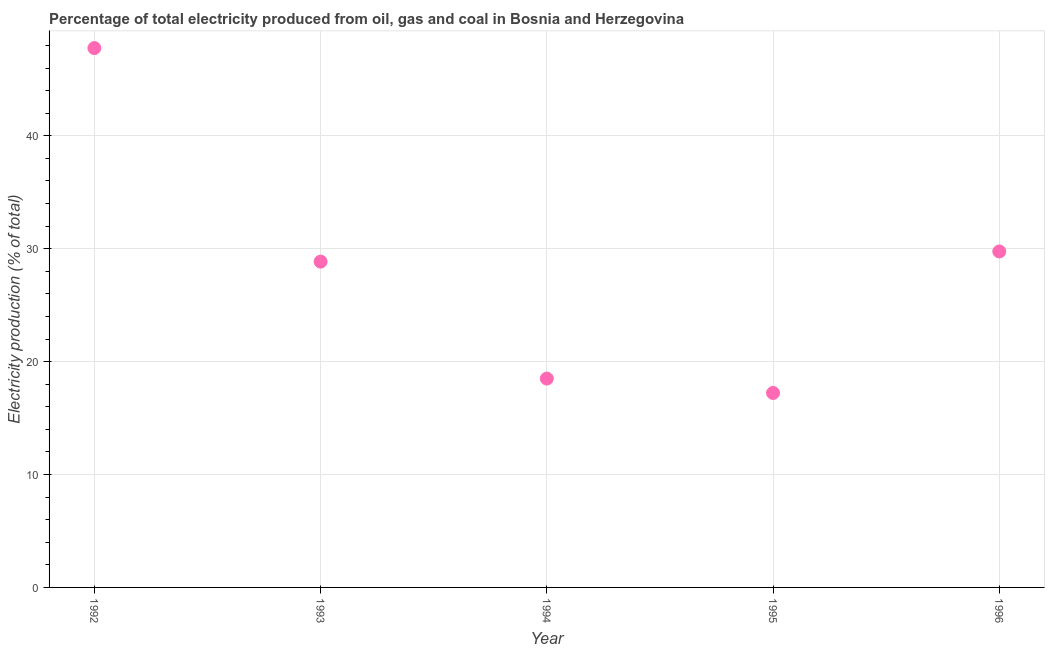What is the electricity production in 1992?
Keep it short and to the point. 47.77. Across all years, what is the maximum electricity production?
Ensure brevity in your answer.  47.77. Across all years, what is the minimum electricity production?
Offer a very short reply. 17.22. In which year was the electricity production minimum?
Offer a terse response. 1995. What is the sum of the electricity production?
Keep it short and to the point. 142.1. What is the difference between the electricity production in 1993 and 1995?
Your answer should be compact. 11.63. What is the average electricity production per year?
Make the answer very short. 28.42. What is the median electricity production?
Keep it short and to the point. 28.85. In how many years, is the electricity production greater than 34 %?
Offer a terse response. 1. What is the ratio of the electricity production in 1992 to that in 1996?
Give a very brief answer. 1.61. Is the difference between the electricity production in 1993 and 1996 greater than the difference between any two years?
Give a very brief answer. No. What is the difference between the highest and the second highest electricity production?
Provide a short and direct response. 18.02. What is the difference between the highest and the lowest electricity production?
Offer a very short reply. 30.55. In how many years, is the electricity production greater than the average electricity production taken over all years?
Offer a very short reply. 3. How many dotlines are there?
Offer a terse response. 1. Are the values on the major ticks of Y-axis written in scientific E-notation?
Give a very brief answer. No. Does the graph contain grids?
Provide a short and direct response. Yes. What is the title of the graph?
Your answer should be very brief. Percentage of total electricity produced from oil, gas and coal in Bosnia and Herzegovina. What is the label or title of the X-axis?
Provide a succinct answer. Year. What is the label or title of the Y-axis?
Give a very brief answer. Electricity production (% of total). What is the Electricity production (% of total) in 1992?
Your answer should be compact. 47.77. What is the Electricity production (% of total) in 1993?
Keep it short and to the point. 28.85. What is the Electricity production (% of total) in 1994?
Offer a very short reply. 18.5. What is the Electricity production (% of total) in 1995?
Keep it short and to the point. 17.22. What is the Electricity production (% of total) in 1996?
Offer a terse response. 29.75. What is the difference between the Electricity production (% of total) in 1992 and 1993?
Your answer should be very brief. 18.92. What is the difference between the Electricity production (% of total) in 1992 and 1994?
Keep it short and to the point. 29.27. What is the difference between the Electricity production (% of total) in 1992 and 1995?
Make the answer very short. 30.55. What is the difference between the Electricity production (% of total) in 1992 and 1996?
Your answer should be compact. 18.02. What is the difference between the Electricity production (% of total) in 1993 and 1994?
Provide a short and direct response. 10.36. What is the difference between the Electricity production (% of total) in 1993 and 1995?
Give a very brief answer. 11.63. What is the difference between the Electricity production (% of total) in 1993 and 1996?
Offer a terse response. -0.9. What is the difference between the Electricity production (% of total) in 1994 and 1995?
Ensure brevity in your answer.  1.27. What is the difference between the Electricity production (% of total) in 1994 and 1996?
Ensure brevity in your answer.  -11.26. What is the difference between the Electricity production (% of total) in 1995 and 1996?
Make the answer very short. -12.53. What is the ratio of the Electricity production (% of total) in 1992 to that in 1993?
Ensure brevity in your answer.  1.66. What is the ratio of the Electricity production (% of total) in 1992 to that in 1994?
Ensure brevity in your answer.  2.58. What is the ratio of the Electricity production (% of total) in 1992 to that in 1995?
Provide a short and direct response. 2.77. What is the ratio of the Electricity production (% of total) in 1992 to that in 1996?
Your response must be concise. 1.6. What is the ratio of the Electricity production (% of total) in 1993 to that in 1994?
Your answer should be compact. 1.56. What is the ratio of the Electricity production (% of total) in 1993 to that in 1995?
Offer a terse response. 1.68. What is the ratio of the Electricity production (% of total) in 1993 to that in 1996?
Provide a succinct answer. 0.97. What is the ratio of the Electricity production (% of total) in 1994 to that in 1995?
Offer a very short reply. 1.07. What is the ratio of the Electricity production (% of total) in 1994 to that in 1996?
Give a very brief answer. 0.62. What is the ratio of the Electricity production (% of total) in 1995 to that in 1996?
Ensure brevity in your answer.  0.58. 